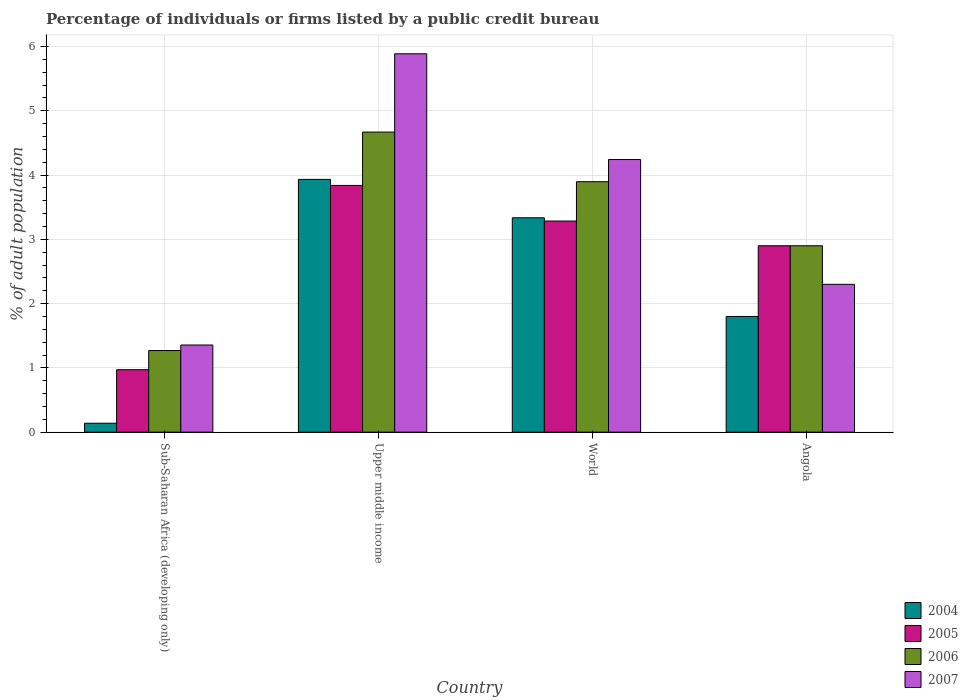How many different coloured bars are there?
Give a very brief answer. 4. Are the number of bars per tick equal to the number of legend labels?
Provide a short and direct response. Yes. Are the number of bars on each tick of the X-axis equal?
Your answer should be compact. Yes. How many bars are there on the 4th tick from the left?
Keep it short and to the point. 4. How many bars are there on the 4th tick from the right?
Provide a succinct answer. 4. What is the label of the 3rd group of bars from the left?
Provide a short and direct response. World. Across all countries, what is the maximum percentage of population listed by a public credit bureau in 2007?
Ensure brevity in your answer.  5.89. Across all countries, what is the minimum percentage of population listed by a public credit bureau in 2005?
Provide a short and direct response. 0.97. In which country was the percentage of population listed by a public credit bureau in 2004 maximum?
Your answer should be very brief. Upper middle income. In which country was the percentage of population listed by a public credit bureau in 2006 minimum?
Your response must be concise. Sub-Saharan Africa (developing only). What is the total percentage of population listed by a public credit bureau in 2006 in the graph?
Ensure brevity in your answer.  12.74. What is the difference between the percentage of population listed by a public credit bureau in 2005 in Upper middle income and that in World?
Offer a terse response. 0.55. What is the difference between the percentage of population listed by a public credit bureau in 2006 in World and the percentage of population listed by a public credit bureau in 2004 in Sub-Saharan Africa (developing only)?
Ensure brevity in your answer.  3.76. What is the average percentage of population listed by a public credit bureau in 2006 per country?
Keep it short and to the point. 3.18. What is the difference between the percentage of population listed by a public credit bureau of/in 2007 and percentage of population listed by a public credit bureau of/in 2006 in Upper middle income?
Offer a very short reply. 1.22. What is the ratio of the percentage of population listed by a public credit bureau in 2006 in Upper middle income to that in World?
Keep it short and to the point. 1.2. Is the percentage of population listed by a public credit bureau in 2006 in Angola less than that in World?
Your response must be concise. Yes. Is the difference between the percentage of population listed by a public credit bureau in 2007 in Angola and World greater than the difference between the percentage of population listed by a public credit bureau in 2006 in Angola and World?
Your answer should be compact. No. What is the difference between the highest and the second highest percentage of population listed by a public credit bureau in 2005?
Give a very brief answer. 0.38. What is the difference between the highest and the lowest percentage of population listed by a public credit bureau in 2007?
Keep it short and to the point. 4.53. In how many countries, is the percentage of population listed by a public credit bureau in 2007 greater than the average percentage of population listed by a public credit bureau in 2007 taken over all countries?
Your answer should be compact. 2. Is the sum of the percentage of population listed by a public credit bureau in 2004 in Angola and Sub-Saharan Africa (developing only) greater than the maximum percentage of population listed by a public credit bureau in 2007 across all countries?
Keep it short and to the point. No. Is it the case that in every country, the sum of the percentage of population listed by a public credit bureau in 2006 and percentage of population listed by a public credit bureau in 2007 is greater than the sum of percentage of population listed by a public credit bureau in 2005 and percentage of population listed by a public credit bureau in 2004?
Your answer should be very brief. No. What does the 2nd bar from the left in Upper middle income represents?
Offer a terse response. 2005. Is it the case that in every country, the sum of the percentage of population listed by a public credit bureau in 2007 and percentage of population listed by a public credit bureau in 2004 is greater than the percentage of population listed by a public credit bureau in 2006?
Offer a very short reply. Yes. Are all the bars in the graph horizontal?
Your response must be concise. No. How many countries are there in the graph?
Your response must be concise. 4. What is the difference between two consecutive major ticks on the Y-axis?
Provide a short and direct response. 1. Are the values on the major ticks of Y-axis written in scientific E-notation?
Provide a short and direct response. No. Does the graph contain grids?
Your answer should be compact. Yes. How are the legend labels stacked?
Your answer should be compact. Vertical. What is the title of the graph?
Make the answer very short. Percentage of individuals or firms listed by a public credit bureau. What is the label or title of the Y-axis?
Your response must be concise. % of adult population. What is the % of adult population of 2004 in Sub-Saharan Africa (developing only)?
Provide a succinct answer. 0.14. What is the % of adult population in 2005 in Sub-Saharan Africa (developing only)?
Provide a short and direct response. 0.97. What is the % of adult population in 2006 in Sub-Saharan Africa (developing only)?
Keep it short and to the point. 1.27. What is the % of adult population of 2007 in Sub-Saharan Africa (developing only)?
Your answer should be very brief. 1.36. What is the % of adult population in 2004 in Upper middle income?
Give a very brief answer. 3.93. What is the % of adult population in 2005 in Upper middle income?
Make the answer very short. 3.84. What is the % of adult population in 2006 in Upper middle income?
Ensure brevity in your answer.  4.67. What is the % of adult population in 2007 in Upper middle income?
Give a very brief answer. 5.89. What is the % of adult population of 2004 in World?
Ensure brevity in your answer.  3.34. What is the % of adult population of 2005 in World?
Your response must be concise. 3.28. What is the % of adult population in 2006 in World?
Provide a short and direct response. 3.9. What is the % of adult population of 2007 in World?
Give a very brief answer. 4.24. What is the % of adult population of 2005 in Angola?
Make the answer very short. 2.9. What is the % of adult population of 2007 in Angola?
Keep it short and to the point. 2.3. Across all countries, what is the maximum % of adult population in 2004?
Offer a very short reply. 3.93. Across all countries, what is the maximum % of adult population in 2005?
Give a very brief answer. 3.84. Across all countries, what is the maximum % of adult population of 2006?
Your answer should be very brief. 4.67. Across all countries, what is the maximum % of adult population of 2007?
Offer a terse response. 5.89. Across all countries, what is the minimum % of adult population in 2004?
Ensure brevity in your answer.  0.14. Across all countries, what is the minimum % of adult population of 2005?
Give a very brief answer. 0.97. Across all countries, what is the minimum % of adult population in 2006?
Your answer should be compact. 1.27. Across all countries, what is the minimum % of adult population in 2007?
Make the answer very short. 1.36. What is the total % of adult population of 2004 in the graph?
Keep it short and to the point. 9.21. What is the total % of adult population of 2005 in the graph?
Give a very brief answer. 10.99. What is the total % of adult population in 2006 in the graph?
Keep it short and to the point. 12.74. What is the total % of adult population in 2007 in the graph?
Your answer should be compact. 13.78. What is the difference between the % of adult population of 2004 in Sub-Saharan Africa (developing only) and that in Upper middle income?
Your answer should be very brief. -3.79. What is the difference between the % of adult population of 2005 in Sub-Saharan Africa (developing only) and that in Upper middle income?
Your answer should be very brief. -2.87. What is the difference between the % of adult population in 2006 in Sub-Saharan Africa (developing only) and that in Upper middle income?
Provide a short and direct response. -3.4. What is the difference between the % of adult population of 2007 in Sub-Saharan Africa (developing only) and that in Upper middle income?
Your answer should be compact. -4.53. What is the difference between the % of adult population in 2004 in Sub-Saharan Africa (developing only) and that in World?
Your answer should be compact. -3.2. What is the difference between the % of adult population of 2005 in Sub-Saharan Africa (developing only) and that in World?
Offer a very short reply. -2.31. What is the difference between the % of adult population of 2006 in Sub-Saharan Africa (developing only) and that in World?
Keep it short and to the point. -2.63. What is the difference between the % of adult population in 2007 in Sub-Saharan Africa (developing only) and that in World?
Make the answer very short. -2.89. What is the difference between the % of adult population in 2004 in Sub-Saharan Africa (developing only) and that in Angola?
Keep it short and to the point. -1.66. What is the difference between the % of adult population of 2005 in Sub-Saharan Africa (developing only) and that in Angola?
Give a very brief answer. -1.93. What is the difference between the % of adult population in 2006 in Sub-Saharan Africa (developing only) and that in Angola?
Keep it short and to the point. -1.63. What is the difference between the % of adult population in 2007 in Sub-Saharan Africa (developing only) and that in Angola?
Make the answer very short. -0.94. What is the difference between the % of adult population in 2004 in Upper middle income and that in World?
Ensure brevity in your answer.  0.6. What is the difference between the % of adult population in 2005 in Upper middle income and that in World?
Ensure brevity in your answer.  0.55. What is the difference between the % of adult population in 2006 in Upper middle income and that in World?
Offer a terse response. 0.77. What is the difference between the % of adult population of 2007 in Upper middle income and that in World?
Give a very brief answer. 1.64. What is the difference between the % of adult population of 2004 in Upper middle income and that in Angola?
Provide a succinct answer. 2.13. What is the difference between the % of adult population in 2005 in Upper middle income and that in Angola?
Give a very brief answer. 0.94. What is the difference between the % of adult population in 2006 in Upper middle income and that in Angola?
Offer a terse response. 1.77. What is the difference between the % of adult population in 2007 in Upper middle income and that in Angola?
Your answer should be compact. 3.59. What is the difference between the % of adult population in 2004 in World and that in Angola?
Your response must be concise. 1.54. What is the difference between the % of adult population of 2005 in World and that in Angola?
Make the answer very short. 0.38. What is the difference between the % of adult population in 2006 in World and that in Angola?
Your response must be concise. 1. What is the difference between the % of adult population of 2007 in World and that in Angola?
Your answer should be very brief. 1.94. What is the difference between the % of adult population in 2004 in Sub-Saharan Africa (developing only) and the % of adult population in 2005 in Upper middle income?
Your answer should be very brief. -3.7. What is the difference between the % of adult population in 2004 in Sub-Saharan Africa (developing only) and the % of adult population in 2006 in Upper middle income?
Your answer should be very brief. -4.53. What is the difference between the % of adult population of 2004 in Sub-Saharan Africa (developing only) and the % of adult population of 2007 in Upper middle income?
Offer a very short reply. -5.75. What is the difference between the % of adult population in 2005 in Sub-Saharan Africa (developing only) and the % of adult population in 2006 in Upper middle income?
Give a very brief answer. -3.7. What is the difference between the % of adult population of 2005 in Sub-Saharan Africa (developing only) and the % of adult population of 2007 in Upper middle income?
Make the answer very short. -4.92. What is the difference between the % of adult population in 2006 in Sub-Saharan Africa (developing only) and the % of adult population in 2007 in Upper middle income?
Ensure brevity in your answer.  -4.62. What is the difference between the % of adult population in 2004 in Sub-Saharan Africa (developing only) and the % of adult population in 2005 in World?
Keep it short and to the point. -3.15. What is the difference between the % of adult population of 2004 in Sub-Saharan Africa (developing only) and the % of adult population of 2006 in World?
Your response must be concise. -3.76. What is the difference between the % of adult population in 2004 in Sub-Saharan Africa (developing only) and the % of adult population in 2007 in World?
Provide a succinct answer. -4.1. What is the difference between the % of adult population in 2005 in Sub-Saharan Africa (developing only) and the % of adult population in 2006 in World?
Keep it short and to the point. -2.92. What is the difference between the % of adult population of 2005 in Sub-Saharan Africa (developing only) and the % of adult population of 2007 in World?
Give a very brief answer. -3.27. What is the difference between the % of adult population of 2006 in Sub-Saharan Africa (developing only) and the % of adult population of 2007 in World?
Your answer should be very brief. -2.97. What is the difference between the % of adult population of 2004 in Sub-Saharan Africa (developing only) and the % of adult population of 2005 in Angola?
Your response must be concise. -2.76. What is the difference between the % of adult population of 2004 in Sub-Saharan Africa (developing only) and the % of adult population of 2006 in Angola?
Your answer should be compact. -2.76. What is the difference between the % of adult population of 2004 in Sub-Saharan Africa (developing only) and the % of adult population of 2007 in Angola?
Make the answer very short. -2.16. What is the difference between the % of adult population of 2005 in Sub-Saharan Africa (developing only) and the % of adult population of 2006 in Angola?
Provide a succinct answer. -1.93. What is the difference between the % of adult population in 2005 in Sub-Saharan Africa (developing only) and the % of adult population in 2007 in Angola?
Offer a very short reply. -1.33. What is the difference between the % of adult population of 2006 in Sub-Saharan Africa (developing only) and the % of adult population of 2007 in Angola?
Your answer should be very brief. -1.03. What is the difference between the % of adult population of 2004 in Upper middle income and the % of adult population of 2005 in World?
Offer a very short reply. 0.65. What is the difference between the % of adult population of 2004 in Upper middle income and the % of adult population of 2006 in World?
Keep it short and to the point. 0.04. What is the difference between the % of adult population of 2004 in Upper middle income and the % of adult population of 2007 in World?
Provide a succinct answer. -0.31. What is the difference between the % of adult population of 2005 in Upper middle income and the % of adult population of 2006 in World?
Provide a short and direct response. -0.06. What is the difference between the % of adult population of 2005 in Upper middle income and the % of adult population of 2007 in World?
Keep it short and to the point. -0.4. What is the difference between the % of adult population of 2006 in Upper middle income and the % of adult population of 2007 in World?
Provide a short and direct response. 0.43. What is the difference between the % of adult population of 2004 in Upper middle income and the % of adult population of 2005 in Angola?
Your answer should be very brief. 1.03. What is the difference between the % of adult population of 2004 in Upper middle income and the % of adult population of 2006 in Angola?
Provide a short and direct response. 1.03. What is the difference between the % of adult population of 2004 in Upper middle income and the % of adult population of 2007 in Angola?
Your answer should be compact. 1.63. What is the difference between the % of adult population of 2005 in Upper middle income and the % of adult population of 2006 in Angola?
Give a very brief answer. 0.94. What is the difference between the % of adult population in 2005 in Upper middle income and the % of adult population in 2007 in Angola?
Ensure brevity in your answer.  1.54. What is the difference between the % of adult population of 2006 in Upper middle income and the % of adult population of 2007 in Angola?
Offer a terse response. 2.37. What is the difference between the % of adult population in 2004 in World and the % of adult population in 2005 in Angola?
Provide a succinct answer. 0.44. What is the difference between the % of adult population in 2004 in World and the % of adult population in 2006 in Angola?
Your answer should be very brief. 0.44. What is the difference between the % of adult population of 2004 in World and the % of adult population of 2007 in Angola?
Your answer should be compact. 1.04. What is the difference between the % of adult population of 2005 in World and the % of adult population of 2006 in Angola?
Make the answer very short. 0.38. What is the difference between the % of adult population in 2005 in World and the % of adult population in 2007 in Angola?
Your answer should be very brief. 0.98. What is the difference between the % of adult population of 2006 in World and the % of adult population of 2007 in Angola?
Your response must be concise. 1.6. What is the average % of adult population in 2004 per country?
Your answer should be compact. 2.3. What is the average % of adult population of 2005 per country?
Give a very brief answer. 2.75. What is the average % of adult population of 2006 per country?
Ensure brevity in your answer.  3.18. What is the average % of adult population in 2007 per country?
Ensure brevity in your answer.  3.45. What is the difference between the % of adult population of 2004 and % of adult population of 2005 in Sub-Saharan Africa (developing only)?
Give a very brief answer. -0.83. What is the difference between the % of adult population of 2004 and % of adult population of 2006 in Sub-Saharan Africa (developing only)?
Your response must be concise. -1.13. What is the difference between the % of adult population in 2004 and % of adult population in 2007 in Sub-Saharan Africa (developing only)?
Offer a very short reply. -1.22. What is the difference between the % of adult population of 2005 and % of adult population of 2006 in Sub-Saharan Africa (developing only)?
Offer a very short reply. -0.3. What is the difference between the % of adult population in 2005 and % of adult population in 2007 in Sub-Saharan Africa (developing only)?
Your answer should be compact. -0.38. What is the difference between the % of adult population in 2006 and % of adult population in 2007 in Sub-Saharan Africa (developing only)?
Your answer should be very brief. -0.09. What is the difference between the % of adult population of 2004 and % of adult population of 2005 in Upper middle income?
Your response must be concise. 0.09. What is the difference between the % of adult population of 2004 and % of adult population of 2006 in Upper middle income?
Keep it short and to the point. -0.74. What is the difference between the % of adult population of 2004 and % of adult population of 2007 in Upper middle income?
Make the answer very short. -1.95. What is the difference between the % of adult population in 2005 and % of adult population in 2006 in Upper middle income?
Your answer should be compact. -0.83. What is the difference between the % of adult population in 2005 and % of adult population in 2007 in Upper middle income?
Your answer should be very brief. -2.05. What is the difference between the % of adult population of 2006 and % of adult population of 2007 in Upper middle income?
Offer a terse response. -1.22. What is the difference between the % of adult population of 2004 and % of adult population of 2005 in World?
Offer a terse response. 0.05. What is the difference between the % of adult population in 2004 and % of adult population in 2006 in World?
Ensure brevity in your answer.  -0.56. What is the difference between the % of adult population in 2004 and % of adult population in 2007 in World?
Ensure brevity in your answer.  -0.91. What is the difference between the % of adult population of 2005 and % of adult population of 2006 in World?
Offer a very short reply. -0.61. What is the difference between the % of adult population in 2005 and % of adult population in 2007 in World?
Provide a short and direct response. -0.96. What is the difference between the % of adult population of 2006 and % of adult population of 2007 in World?
Offer a very short reply. -0.35. What is the difference between the % of adult population of 2004 and % of adult population of 2005 in Angola?
Your answer should be very brief. -1.1. What is the difference between the % of adult population of 2004 and % of adult population of 2007 in Angola?
Your answer should be compact. -0.5. What is the difference between the % of adult population in 2005 and % of adult population in 2006 in Angola?
Make the answer very short. 0. What is the difference between the % of adult population of 2005 and % of adult population of 2007 in Angola?
Keep it short and to the point. 0.6. What is the ratio of the % of adult population in 2004 in Sub-Saharan Africa (developing only) to that in Upper middle income?
Your response must be concise. 0.04. What is the ratio of the % of adult population of 2005 in Sub-Saharan Africa (developing only) to that in Upper middle income?
Give a very brief answer. 0.25. What is the ratio of the % of adult population of 2006 in Sub-Saharan Africa (developing only) to that in Upper middle income?
Ensure brevity in your answer.  0.27. What is the ratio of the % of adult population of 2007 in Sub-Saharan Africa (developing only) to that in Upper middle income?
Give a very brief answer. 0.23. What is the ratio of the % of adult population of 2004 in Sub-Saharan Africa (developing only) to that in World?
Provide a short and direct response. 0.04. What is the ratio of the % of adult population of 2005 in Sub-Saharan Africa (developing only) to that in World?
Offer a very short reply. 0.3. What is the ratio of the % of adult population of 2006 in Sub-Saharan Africa (developing only) to that in World?
Your answer should be very brief. 0.33. What is the ratio of the % of adult population in 2007 in Sub-Saharan Africa (developing only) to that in World?
Offer a terse response. 0.32. What is the ratio of the % of adult population in 2004 in Sub-Saharan Africa (developing only) to that in Angola?
Provide a short and direct response. 0.08. What is the ratio of the % of adult population in 2005 in Sub-Saharan Africa (developing only) to that in Angola?
Offer a terse response. 0.34. What is the ratio of the % of adult population of 2006 in Sub-Saharan Africa (developing only) to that in Angola?
Your response must be concise. 0.44. What is the ratio of the % of adult population in 2007 in Sub-Saharan Africa (developing only) to that in Angola?
Your answer should be compact. 0.59. What is the ratio of the % of adult population of 2004 in Upper middle income to that in World?
Provide a short and direct response. 1.18. What is the ratio of the % of adult population in 2005 in Upper middle income to that in World?
Ensure brevity in your answer.  1.17. What is the ratio of the % of adult population in 2006 in Upper middle income to that in World?
Offer a terse response. 1.2. What is the ratio of the % of adult population in 2007 in Upper middle income to that in World?
Keep it short and to the point. 1.39. What is the ratio of the % of adult population in 2004 in Upper middle income to that in Angola?
Provide a succinct answer. 2.18. What is the ratio of the % of adult population of 2005 in Upper middle income to that in Angola?
Offer a terse response. 1.32. What is the ratio of the % of adult population in 2006 in Upper middle income to that in Angola?
Ensure brevity in your answer.  1.61. What is the ratio of the % of adult population in 2007 in Upper middle income to that in Angola?
Your answer should be compact. 2.56. What is the ratio of the % of adult population of 2004 in World to that in Angola?
Make the answer very short. 1.85. What is the ratio of the % of adult population of 2005 in World to that in Angola?
Make the answer very short. 1.13. What is the ratio of the % of adult population in 2006 in World to that in Angola?
Offer a terse response. 1.34. What is the ratio of the % of adult population of 2007 in World to that in Angola?
Make the answer very short. 1.84. What is the difference between the highest and the second highest % of adult population in 2004?
Keep it short and to the point. 0.6. What is the difference between the highest and the second highest % of adult population in 2005?
Offer a very short reply. 0.55. What is the difference between the highest and the second highest % of adult population in 2006?
Your answer should be very brief. 0.77. What is the difference between the highest and the second highest % of adult population in 2007?
Offer a terse response. 1.64. What is the difference between the highest and the lowest % of adult population of 2004?
Provide a succinct answer. 3.79. What is the difference between the highest and the lowest % of adult population of 2005?
Keep it short and to the point. 2.87. What is the difference between the highest and the lowest % of adult population in 2006?
Provide a succinct answer. 3.4. What is the difference between the highest and the lowest % of adult population in 2007?
Your answer should be compact. 4.53. 